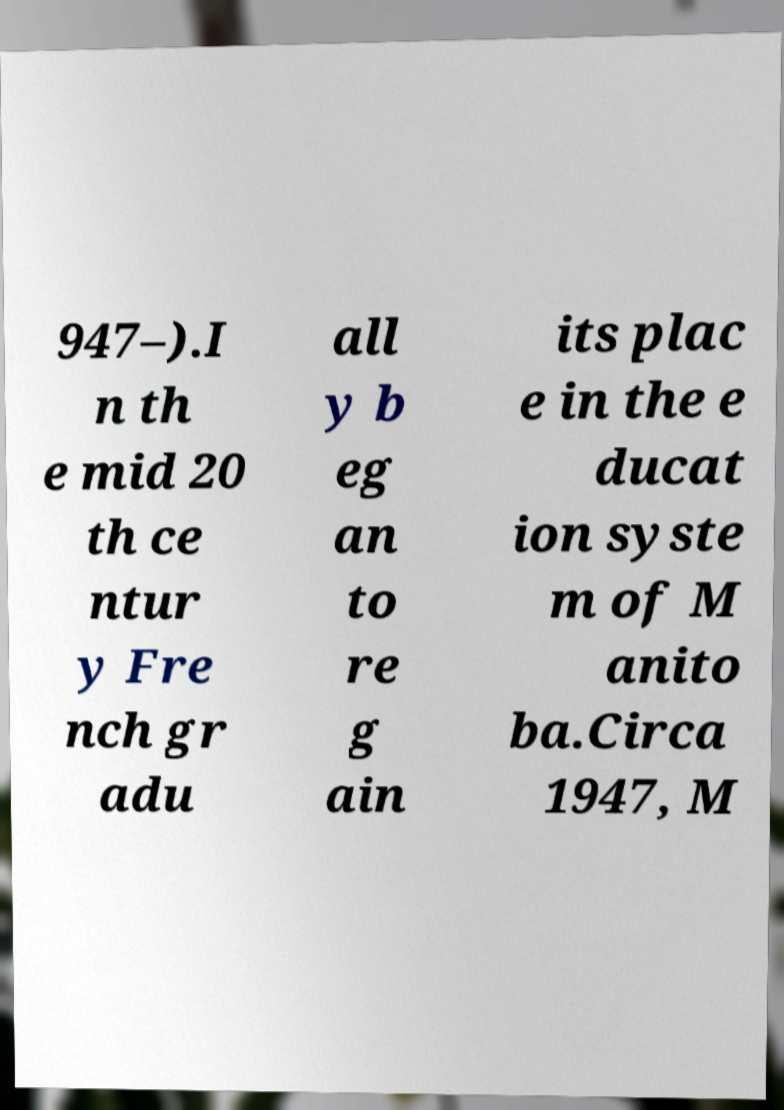Please read and relay the text visible in this image. What does it say? 947–).I n th e mid 20 th ce ntur y Fre nch gr adu all y b eg an to re g ain its plac e in the e ducat ion syste m of M anito ba.Circa 1947, M 